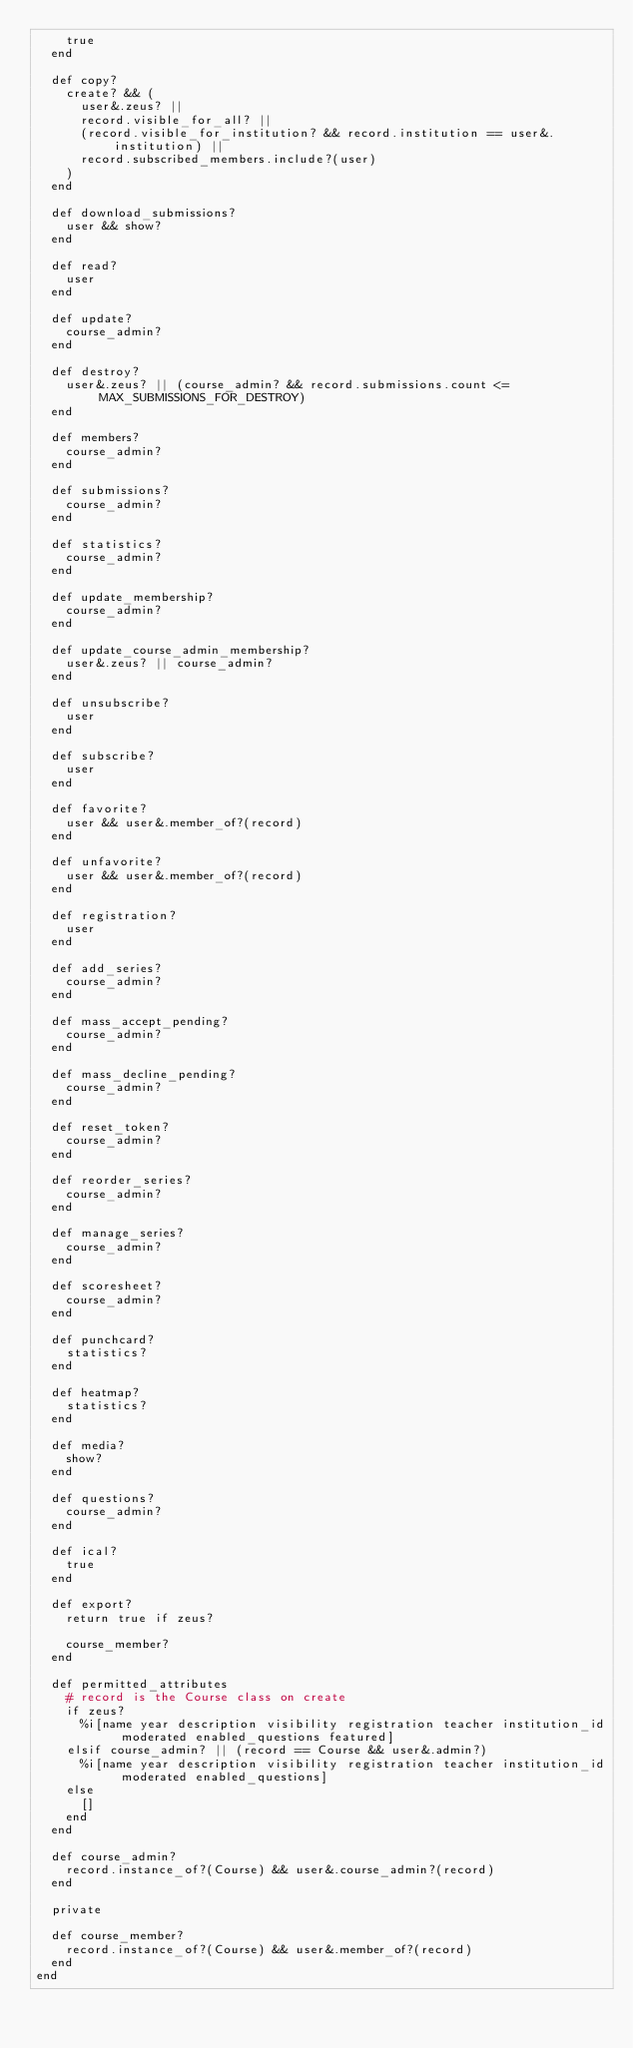<code> <loc_0><loc_0><loc_500><loc_500><_Ruby_>    true
  end

  def copy?
    create? && (
      user&.zeus? ||
      record.visible_for_all? ||
      (record.visible_for_institution? && record.institution == user&.institution) ||
      record.subscribed_members.include?(user)
    )
  end

  def download_submissions?
    user && show?
  end

  def read?
    user
  end

  def update?
    course_admin?
  end

  def destroy?
    user&.zeus? || (course_admin? && record.submissions.count <= MAX_SUBMISSIONS_FOR_DESTROY)
  end

  def members?
    course_admin?
  end

  def submissions?
    course_admin?
  end

  def statistics?
    course_admin?
  end

  def update_membership?
    course_admin?
  end

  def update_course_admin_membership?
    user&.zeus? || course_admin?
  end

  def unsubscribe?
    user
  end

  def subscribe?
    user
  end

  def favorite?
    user && user&.member_of?(record)
  end

  def unfavorite?
    user && user&.member_of?(record)
  end

  def registration?
    user
  end

  def add_series?
    course_admin?
  end

  def mass_accept_pending?
    course_admin?
  end

  def mass_decline_pending?
    course_admin?
  end

  def reset_token?
    course_admin?
  end

  def reorder_series?
    course_admin?
  end

  def manage_series?
    course_admin?
  end

  def scoresheet?
    course_admin?
  end

  def punchcard?
    statistics?
  end

  def heatmap?
    statistics?
  end

  def media?
    show?
  end

  def questions?
    course_admin?
  end

  def ical?
    true
  end

  def export?
    return true if zeus?

    course_member?
  end

  def permitted_attributes
    # record is the Course class on create
    if zeus?
      %i[name year description visibility registration teacher institution_id moderated enabled_questions featured]
    elsif course_admin? || (record == Course && user&.admin?)
      %i[name year description visibility registration teacher institution_id moderated enabled_questions]
    else
      []
    end
  end

  def course_admin?
    record.instance_of?(Course) && user&.course_admin?(record)
  end

  private

  def course_member?
    record.instance_of?(Course) && user&.member_of?(record)
  end
end
</code> 